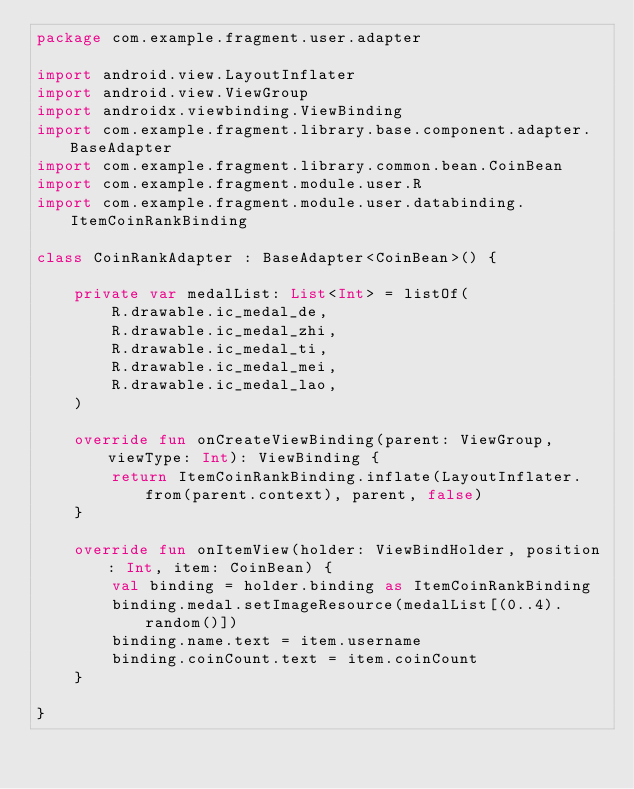<code> <loc_0><loc_0><loc_500><loc_500><_Kotlin_>package com.example.fragment.user.adapter

import android.view.LayoutInflater
import android.view.ViewGroup
import androidx.viewbinding.ViewBinding
import com.example.fragment.library.base.component.adapter.BaseAdapter
import com.example.fragment.library.common.bean.CoinBean
import com.example.fragment.module.user.R
import com.example.fragment.module.user.databinding.ItemCoinRankBinding

class CoinRankAdapter : BaseAdapter<CoinBean>() {

    private var medalList: List<Int> = listOf(
        R.drawable.ic_medal_de,
        R.drawable.ic_medal_zhi,
        R.drawable.ic_medal_ti,
        R.drawable.ic_medal_mei,
        R.drawable.ic_medal_lao,
    )

    override fun onCreateViewBinding(parent: ViewGroup, viewType: Int): ViewBinding {
        return ItemCoinRankBinding.inflate(LayoutInflater.from(parent.context), parent, false)
    }

    override fun onItemView(holder: ViewBindHolder, position: Int, item: CoinBean) {
        val binding = holder.binding as ItemCoinRankBinding
        binding.medal.setImageResource(medalList[(0..4).random()])
        binding.name.text = item.username
        binding.coinCount.text = item.coinCount
    }

}</code> 